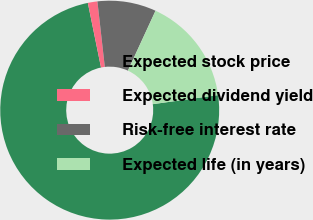Convert chart. <chart><loc_0><loc_0><loc_500><loc_500><pie_chart><fcel>Expected stock price<fcel>Expected dividend yield<fcel>Risk-free interest rate<fcel>Expected life (in years)<nl><fcel>74.0%<fcel>1.41%<fcel>8.67%<fcel>15.93%<nl></chart> 